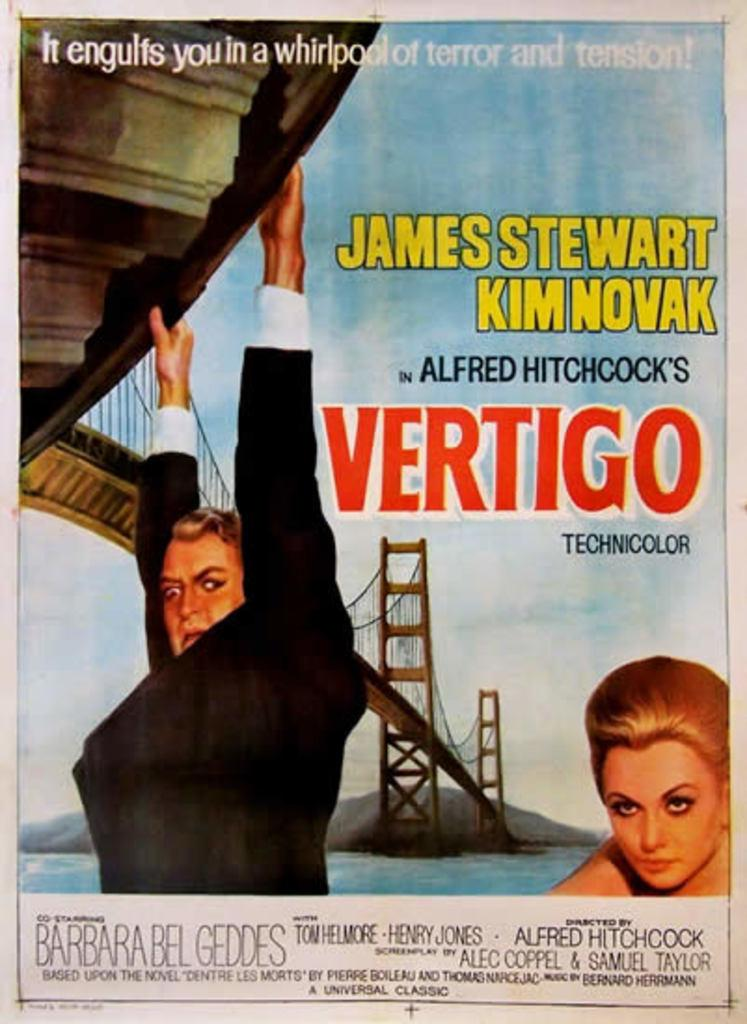Provide a one-sentence caption for the provided image. A poster about the movie Vertigo featuring a man and a blonde woman. 